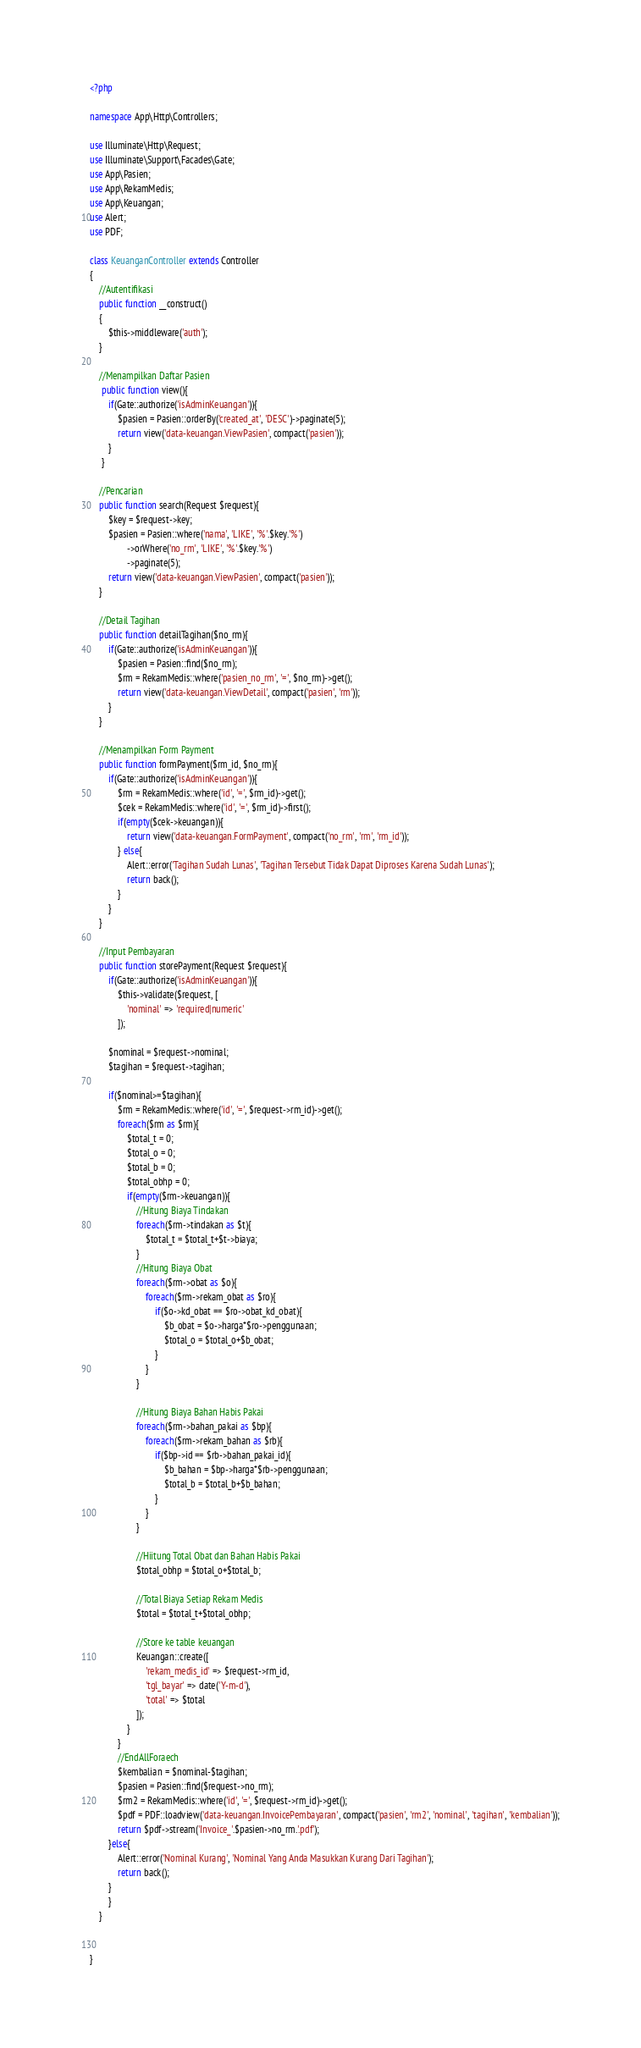<code> <loc_0><loc_0><loc_500><loc_500><_PHP_><?php

namespace App\Http\Controllers;

use Illuminate\Http\Request;
use Illuminate\Support\Facades\Gate;
use App\Pasien;
use App\RekamMedis;
use App\Keuangan;
use Alert;
use PDF;

class KeuanganController extends Controller
{
    //Autentifikasi
    public function __construct()
    {
        $this->middleware('auth');
    }

    //Menampilkan Daftar Pasien
     public function view(){
        if(Gate::authorize('isAdminKeuangan')){
            $pasien = Pasien::orderBy('created_at', 'DESC')->paginate(5);
            return view('data-keuangan.ViewPasien', compact('pasien'));
        }
     }

    //Pencarian
    public function search(Request $request){
        $key = $request->key;
        $pasien = Pasien::where('nama', 'LIKE', '%'.$key.'%')
                ->orWhere('no_rm', 'LIKE', '%'.$key.'%')
                ->paginate(5);
        return view('data-keuangan.ViewPasien', compact('pasien'));
    }

    //Detail Tagihan
    public function detailTagihan($no_rm){
        if(Gate::authorize('isAdminKeuangan')){
            $pasien = Pasien::find($no_rm);
            $rm = RekamMedis::where('pasien_no_rm', '=', $no_rm)->get();
            return view('data-keuangan.ViewDetail', compact('pasien', 'rm'));
        }
    }

    //Menampilkan Form Payment
    public function formPayment($rm_id, $no_rm){
        if(Gate::authorize('isAdminKeuangan')){
            $rm = RekamMedis::where('id', '=', $rm_id)->get();
            $cek = RekamMedis::where('id', '=', $rm_id)->first();
            if(empty($cek->keuangan)){
                return view('data-keuangan.FormPayment', compact('no_rm', 'rm', 'rm_id'));
            } else{
                Alert::error('Tagihan Sudah Lunas', 'Tagihan Tersebut Tidak Dapat Diproses Karena Sudah Lunas');
                return back();
            }
        }
    }

    //Input Pembayaran
    public function storePayment(Request $request){
        if(Gate::authorize('isAdminKeuangan')){
            $this->validate($request, [
                'nominal' => 'required|numeric'
            ]);

        $nominal = $request->nominal;
        $tagihan = $request->tagihan;

        if($nominal>=$tagihan){
            $rm = RekamMedis::where('id', '=', $request->rm_id)->get();
            foreach($rm as $rm){
                $total_t = 0;
                $total_o = 0;
                $total_b = 0;
                $total_obhp = 0;
                if(empty($rm->keuangan)){
                    //Hitung Biaya Tindakan
                    foreach($rm->tindakan as $t){
                        $total_t = $total_t+$t->biaya;
                    }
                    //Hitung Biaya Obat
                    foreach($rm->obat as $o){
                        foreach($rm->rekam_obat as $ro){
                            if($o->kd_obat == $ro->obat_kd_obat){
                                $b_obat = $o->harga*$ro->penggunaan;
                                $total_o = $total_o+$b_obat;
                            }
                        }
                    }

                    //Hitung Biaya Bahan Habis Pakai
                    foreach($rm->bahan_pakai as $bp){
                        foreach($rm->rekam_bahan as $rb){
                            if($bp->id == $rb->bahan_pakai_id){
                                $b_bahan = $bp->harga*$rb->penggunaan;
                                $total_b = $total_b+$b_bahan;
                            }
                        }
                    }

                    //Hiitung Total Obat dan Bahan Habis Pakai
                    $total_obhp = $total_o+$total_b;

                    //Total Biaya Setiap Rekam Medis
                    $total = $total_t+$total_obhp;

                    //Store ke table keuangan
                    Keuangan::create([
                        'rekam_medis_id' => $request->rm_id,
                        'tgl_bayar' => date('Y-m-d'),
                        'total' => $total
                    ]);
                }
            }
            //EndAllForaech
            $kembalian = $nominal-$tagihan;
            $pasien = Pasien::find($request->no_rm);
            $rm2 = RekamMedis::where('id', '=', $request->rm_id)->get();
            $pdf = PDF::loadview('data-keuangan.InvoicePembayaran', compact('pasien', 'rm2', 'nominal', 'tagihan', 'kembalian'));
            return $pdf->stream('Invoice_'.$pasien->no_rm.'.pdf');
        }else{
            Alert::error('Nominal Kurang', 'Nominal Yang Anda Masukkan Kurang Dari Tagihan');
            return back();
        }
        }
    }


}
</code> 